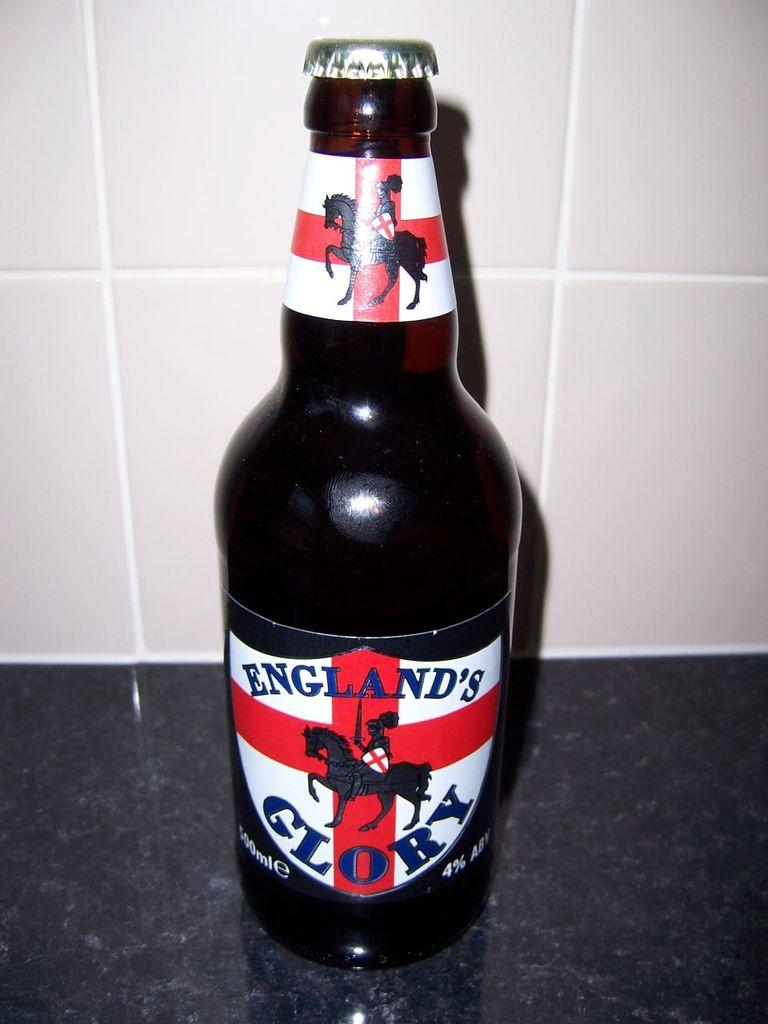<image>
Offer a succinct explanation of the picture presented. A bottle of England's Glory with a label that features a knight on a horse. 